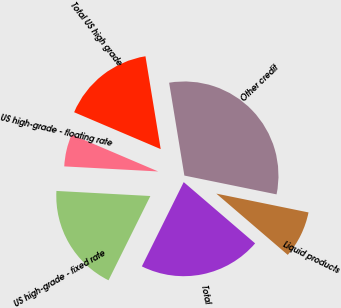Convert chart. <chart><loc_0><loc_0><loc_500><loc_500><pie_chart><fcel>US high-grade - fixed rate<fcel>US high-grade - floating rate<fcel>Total US high grade<fcel>Other credit<fcel>Liquid products<fcel>Total<nl><fcel>18.52%<fcel>5.55%<fcel>16.0%<fcel>30.79%<fcel>8.08%<fcel>21.05%<nl></chart> 